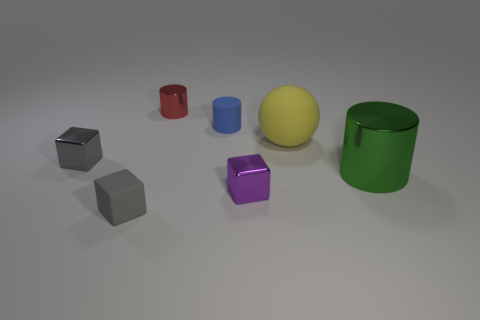Is there any other thing that has the same size as the green object?
Keep it short and to the point. Yes. What number of things are either red shiny cylinders or blocks?
Provide a succinct answer. 4. Is there a matte ball that has the same size as the purple block?
Give a very brief answer. No. What shape is the large yellow matte thing?
Keep it short and to the point. Sphere. Are there more big metal objects behind the red object than tiny blue matte cylinders on the left side of the green cylinder?
Ensure brevity in your answer.  No. Does the metal cylinder that is in front of the small matte cylinder have the same color as the matte thing behind the yellow matte ball?
Provide a succinct answer. No. What shape is the gray matte object that is the same size as the red cylinder?
Ensure brevity in your answer.  Cube. Are there any small gray things that have the same shape as the yellow thing?
Give a very brief answer. No. Is the material of the gray cube behind the tiny gray rubber object the same as the cylinder that is to the right of the tiny rubber cylinder?
Your answer should be very brief. Yes. The small metal thing that is the same color as the matte block is what shape?
Offer a terse response. Cube. 